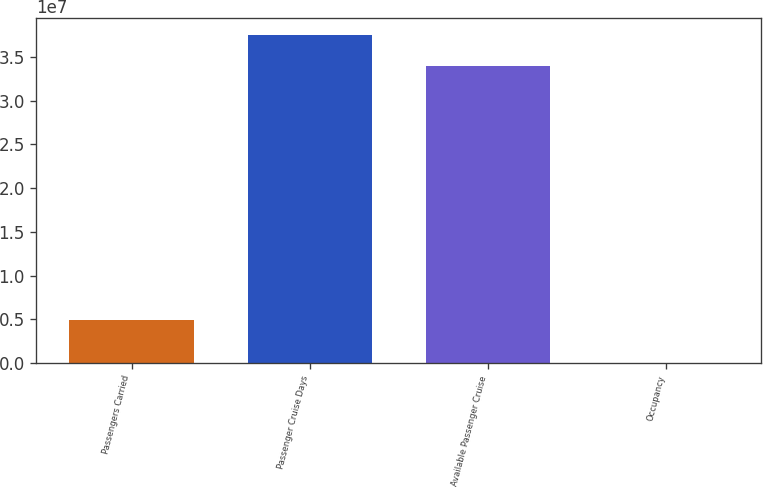<chart> <loc_0><loc_0><loc_500><loc_500><bar_chart><fcel>Passengers Carried<fcel>Passenger Cruise Days<fcel>Available Passenger Cruise<fcel>Occupancy<nl><fcel>4.88476e+06<fcel>3.7531e+07<fcel>3.39749e+07<fcel>104.7<nl></chart> 